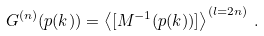<formula> <loc_0><loc_0><loc_500><loc_500>G ^ { ( n ) } ( p ( k ) ) = \left \langle [ M ^ { - 1 } ( p ( k ) ) ] \right \rangle ^ { ( l = 2 n ) } \, .</formula> 